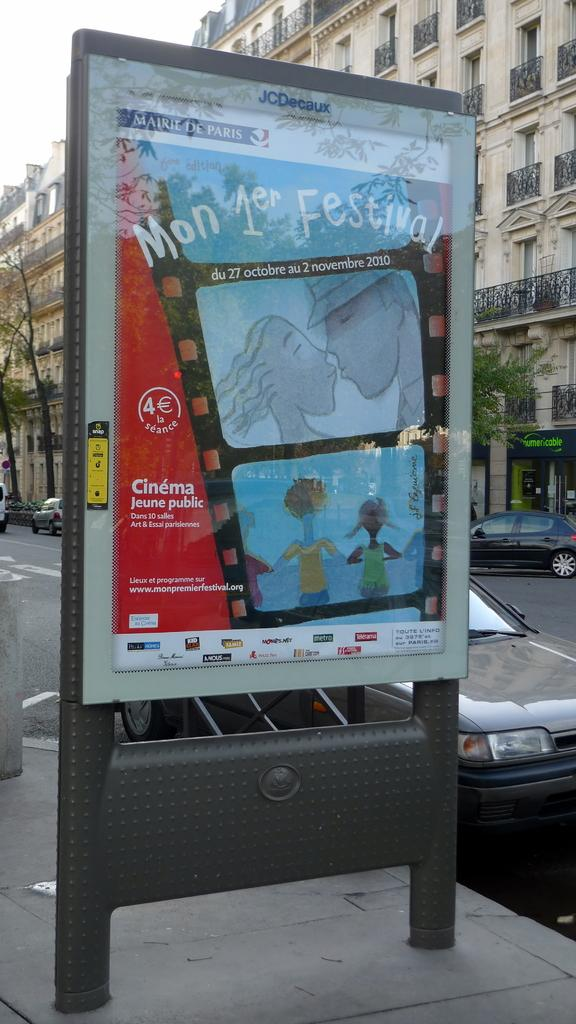<image>
Share a concise interpretation of the image provided. A sign advertises a festival and has pictures of people on it. 